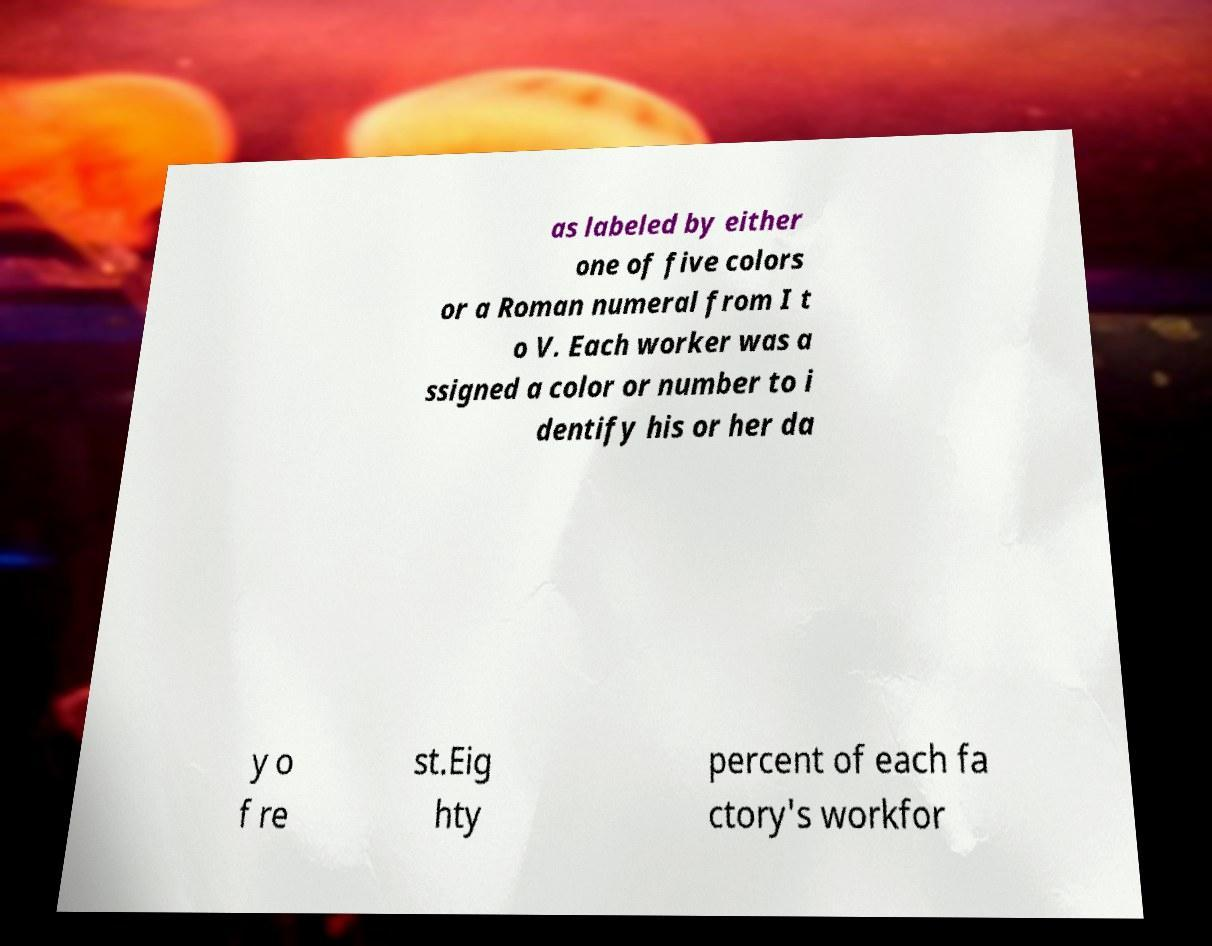Could you extract and type out the text from this image? as labeled by either one of five colors or a Roman numeral from I t o V. Each worker was a ssigned a color or number to i dentify his or her da y o f re st.Eig hty percent of each fa ctory's workfor 